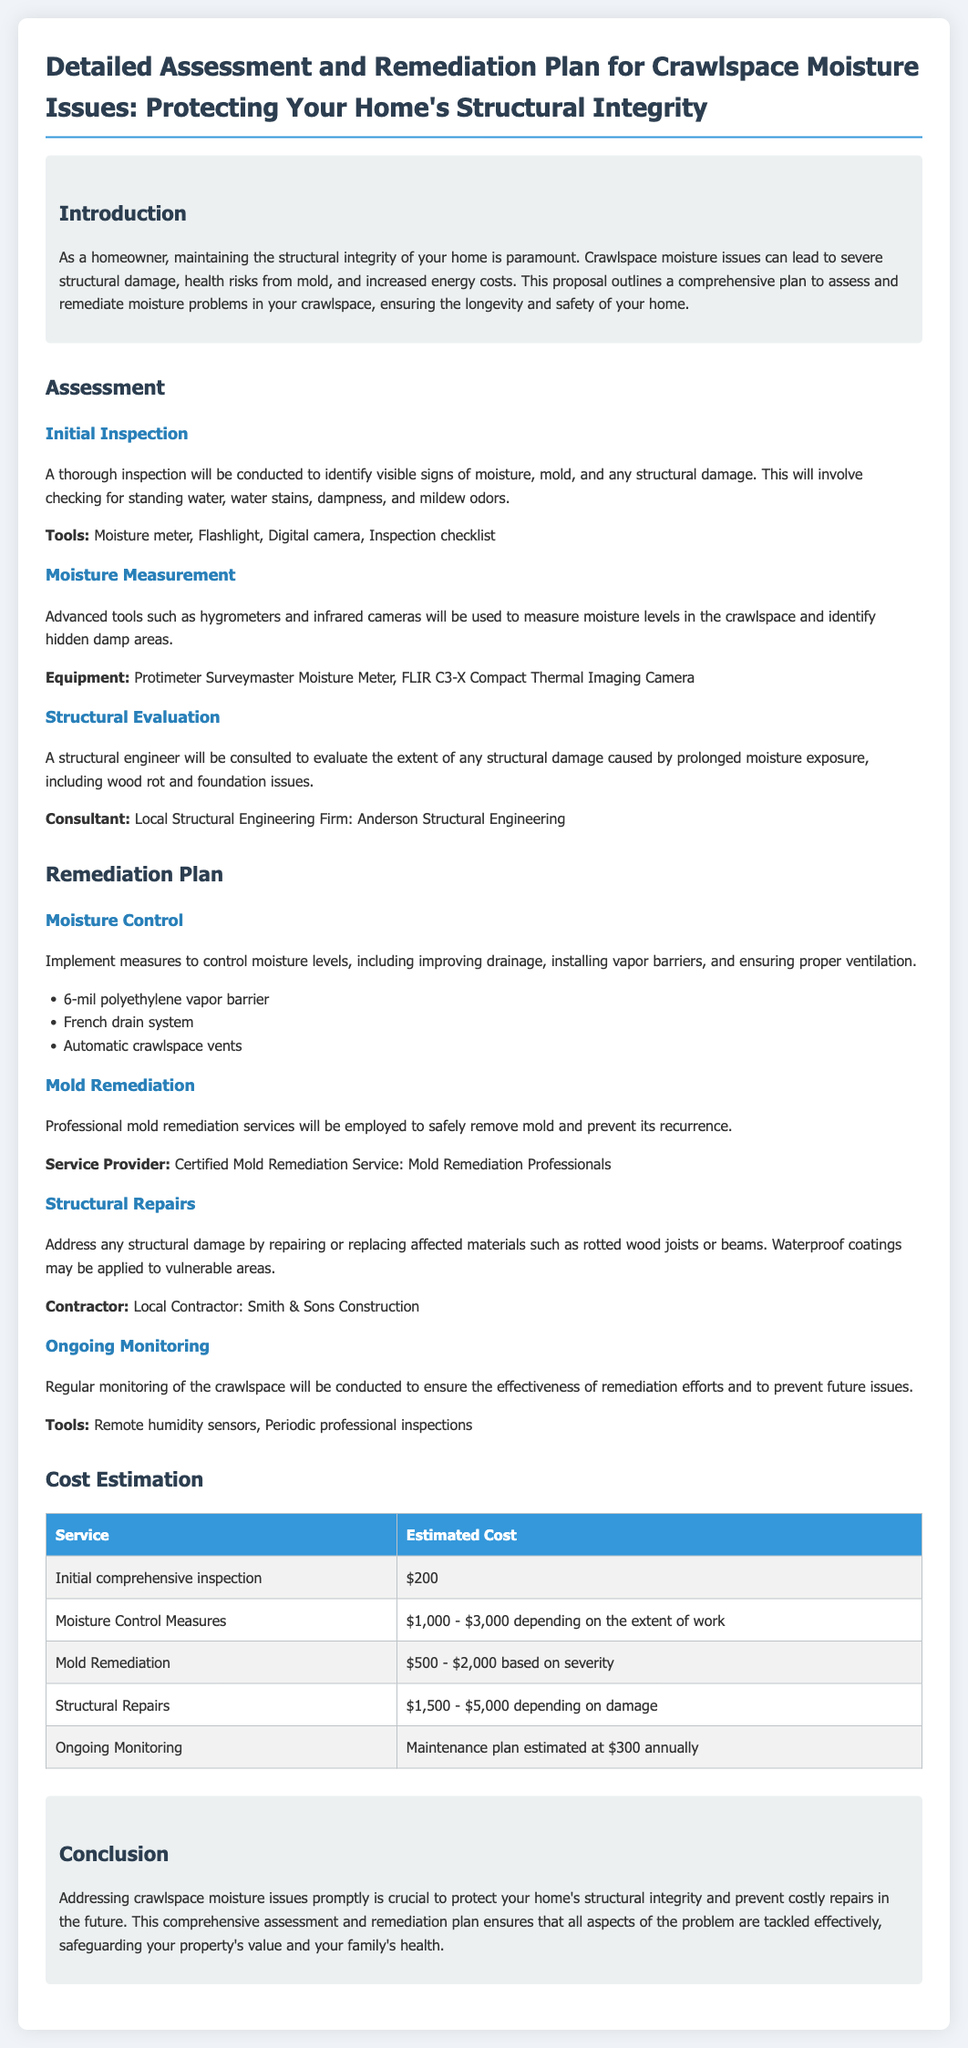What is the title of the proposal? The title can be found at the top of the document and states the focus of the proposal regarding moisture issues.
Answer: Detailed Assessment and Remediation Plan for Crawlspace Moisture Issues: Protecting Your Home's Structural Integrity Who will conduct the initial inspection? The document specifies the involvement of professionals for the initial inspection but does not name an individual; it just mentions a thorough inspection conducted by the proposal team.
Answer: Proposal team What tools will be used for moisture measurement? The moisture measurement section lists specific equipment to be used during the assessment.
Answer: Protimeter Surveymaster Moisture Meter, FLIR C3-X Compact Thermal Imaging Camera What is the estimated cost for structural repairs? The document provides a range for the cost of structural repairs, providing clarity on the budgeting needed.
Answer: $1,500 - $5,000 Which contractor is mentioned for structural repairs? The document specifically names a contractor that will handle the structural repairs as part of the remediation plan.
Answer: Smith & Sons Construction What is one of the moisture control measures listed? The document mentions several measures to control moisture, highlighting the various techniques included in the plan.
Answer: 6-mil polyethylene vapor barrier How much is the maintenance plan for ongoing monitoring estimated? The document notes the estimated annual cost to maintain the monitoring plan for crawlspace moisture issues.
Answer: $300 annually What will be implemented to ensure proper ventilation? The remediation plan suggests specific installations that are meant to aid in ventilation as part of moisture control.
Answer: Automatic crawlspace vents What is the name of the consultant for structural evaluation? The document mentions the local structural engineering firm responsible for assessing any structural damage due to moisture.
Answer: Anderson Structural Engineering 